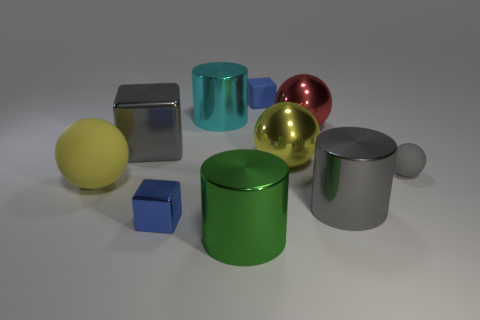There is a small metallic object that is the same color as the rubber block; what is its shape?
Your answer should be compact. Cube. What material is the other tiny blue thing that is the same shape as the tiny shiny object?
Your response must be concise. Rubber. What number of other things are the same size as the green shiny cylinder?
Keep it short and to the point. 6. What size is the rubber cube that is the same color as the tiny metal thing?
Your answer should be compact. Small. Does the blue object that is behind the gray cube have the same shape as the large red metallic object?
Offer a terse response. No. What number of other things are the same shape as the large red shiny thing?
Your response must be concise. 3. There is a small blue thing behind the red ball; what shape is it?
Offer a very short reply. Cube. Is there a big red thing made of the same material as the large red ball?
Offer a terse response. No. Does the tiny rubber object that is on the right side of the red sphere have the same color as the small metallic object?
Make the answer very short. No. What size is the red object?
Your answer should be compact. Large. 